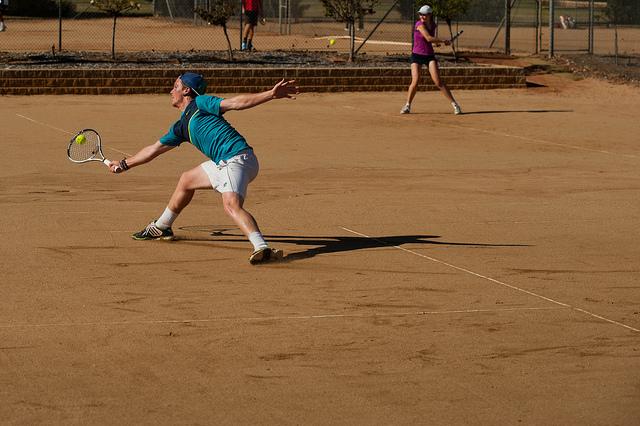What brand are the man's shoes?
Concise answer only. Adidas. How many people are on the other team?
Short answer required. 2. What sport is this?
Write a very short answer. Tennis. Is the tennis ball above the racket?
Quick response, please. Yes. Which game is being played?
Answer briefly. Tennis. Is the guy alone in court?
Be succinct. No. What is the guy in the blue shirt reaching for?
Give a very brief answer. Tennis ball. 